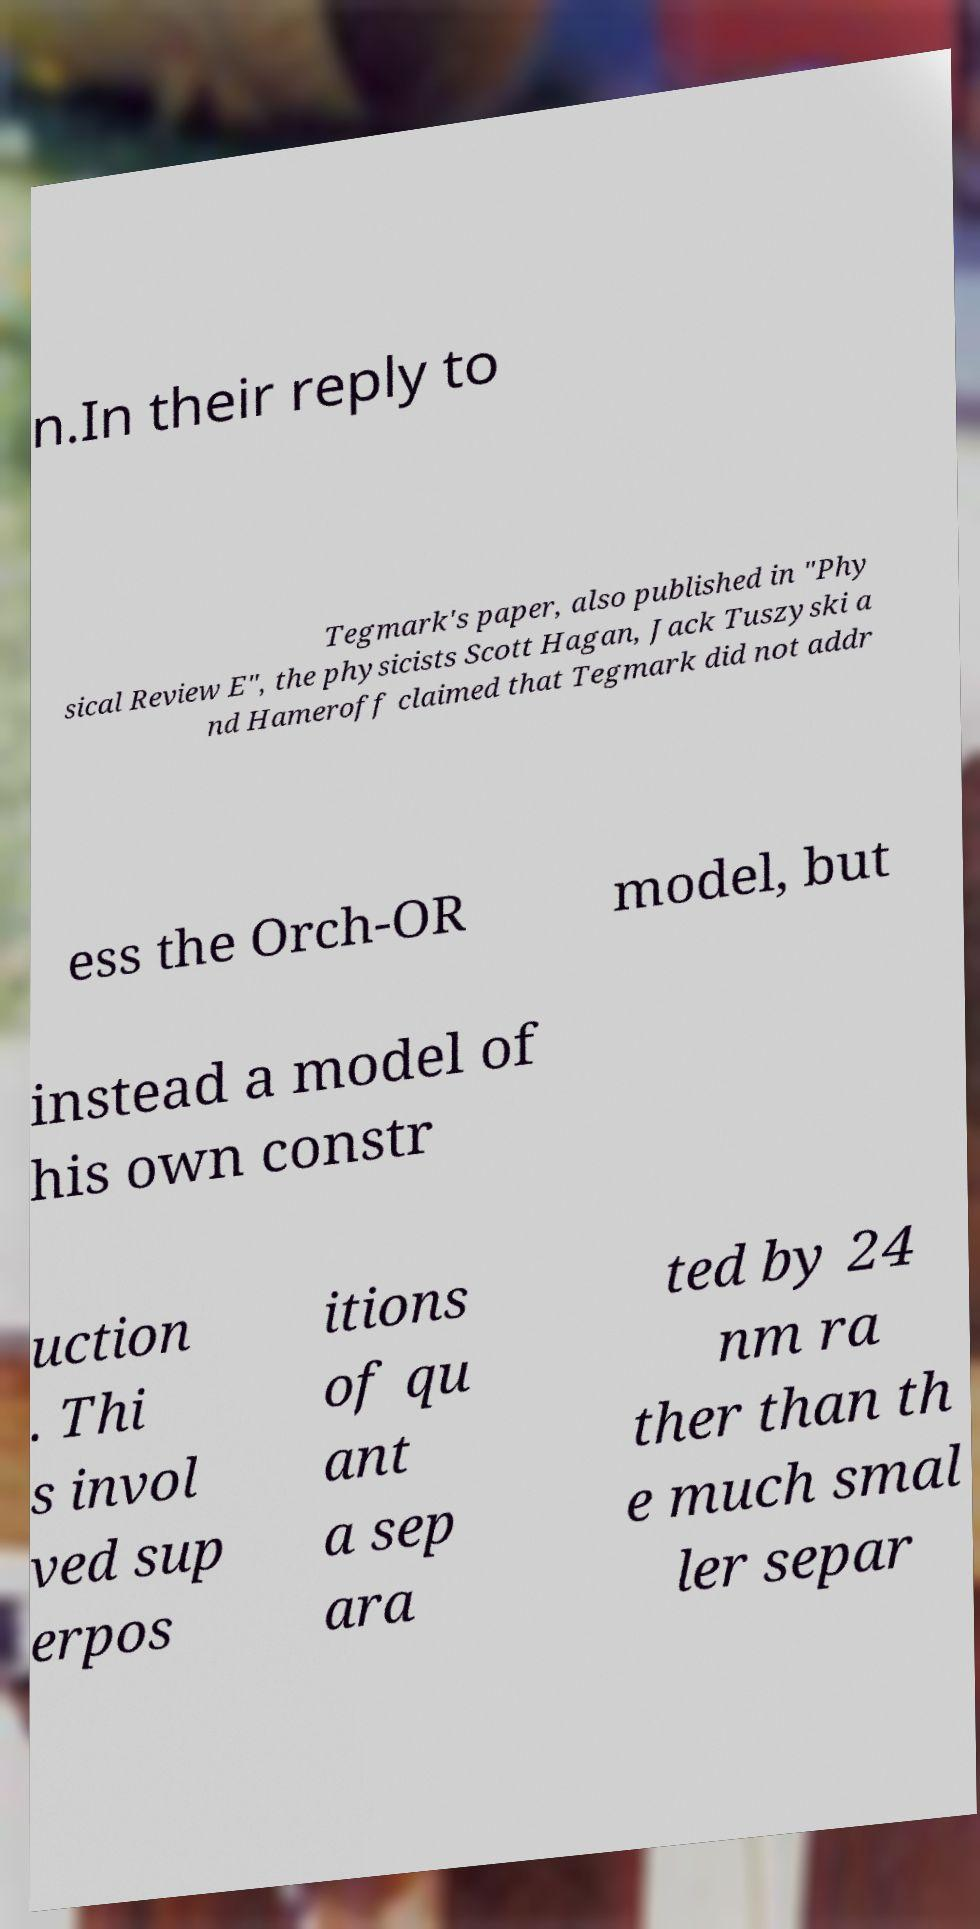Please read and relay the text visible in this image. What does it say? n.In their reply to Tegmark's paper, also published in "Phy sical Review E", the physicists Scott Hagan, Jack Tuszyski a nd Hameroff claimed that Tegmark did not addr ess the Orch-OR model, but instead a model of his own constr uction . Thi s invol ved sup erpos itions of qu ant a sep ara ted by 24 nm ra ther than th e much smal ler separ 